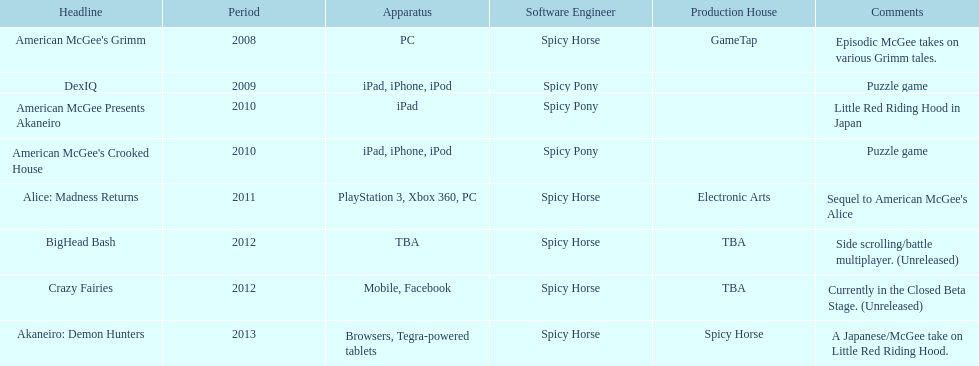What are the number of times an ipad was used as a platform? 3. 